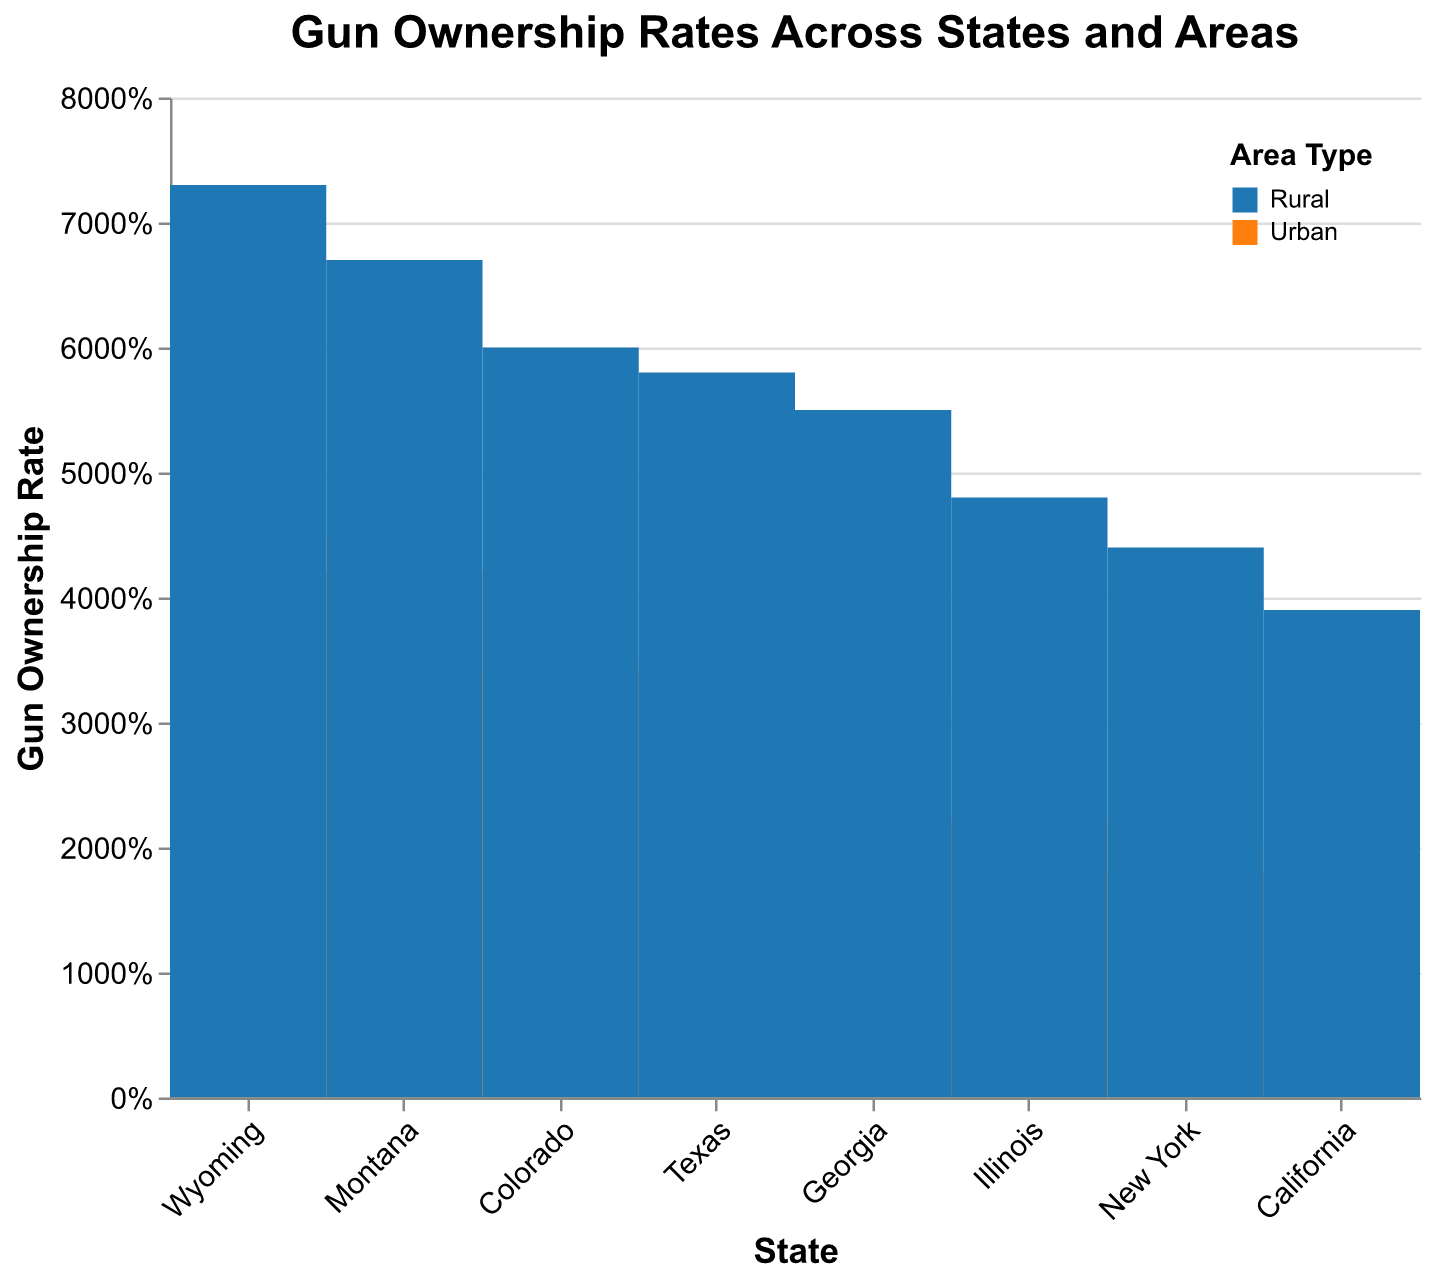What is the title of the figure? The title of the figure is displayed at the top center, indicating the main topic of the plot. It helps to understand the overall context of the visualized data
Answer: Gun Ownership Rates Across States and Areas How are the different areas distinguished in the plot? Different areas (Urban and Rural) are distinguished using different colors. The legend at the top-right corner indicates the color associated with each area type
Answer: By color Which state has the highest rural gun ownership rate? By looking at the heights of the Rural sections in each state, we can see which state's Rural area has the highest value. Wyoming has the tallest bar in the Rural section
Answer: Wyoming What is the approximate gun ownership rate for Urban areas in Montana? Locate the Urban section for Montana and read the height of the bar. The plot shows it is around 42%
Answer: 42% Which state shows the smallest difference in ownership rates between Urban and Rural areas? Compare the Urban and Rural sections of each state to find the smallest difference. Illinois shows a difference of 26% (48% Rural - 22% Urban) which is the smallest among the states listed
Answer: Illinois In which state is the ownership rate disparity between Urban and Rural areas the largest? To find the largest disparity, look at the differences in bar heights between Urban and Rural areas across the states. Wyoming has the largest disparity with a difference of 28% (73% Rural - 45% Urban)
Answer: Wyoming How do the gun ownership rates in Urban areas of Texas compare to those in Urban areas of Georgia? To compare, look at the heights of the Urban sections for Texas and Georgia. Texas has a rate of 35% and Georgia has a rate of 32%; thus, Texas has a slightly higher rate
Answer: Texas has a slightly higher rate What is the range of gun ownership rates in Rural areas across all states? Identify the smallest and largest values in the Rural sections across all states. The smallest is California at 39%, and the largest is Wyoming at 73%. The range is 73% - 39% = 34%
Answer: 34% Which state has the lowest urban gun ownership rate, and what is that rate? Look at the Urban sections of all states to find the lowest value which is New York at 18%
Answer: New York, 18% Among the states examined, which has the closest gun ownership rates between Urban and Rural areas? To find the closest rates, compare the difference between Urban and Rural bars for each state. Illinois shows the least difference at 26% (48% Rural - 22% Urban)
Answer: Illinois 